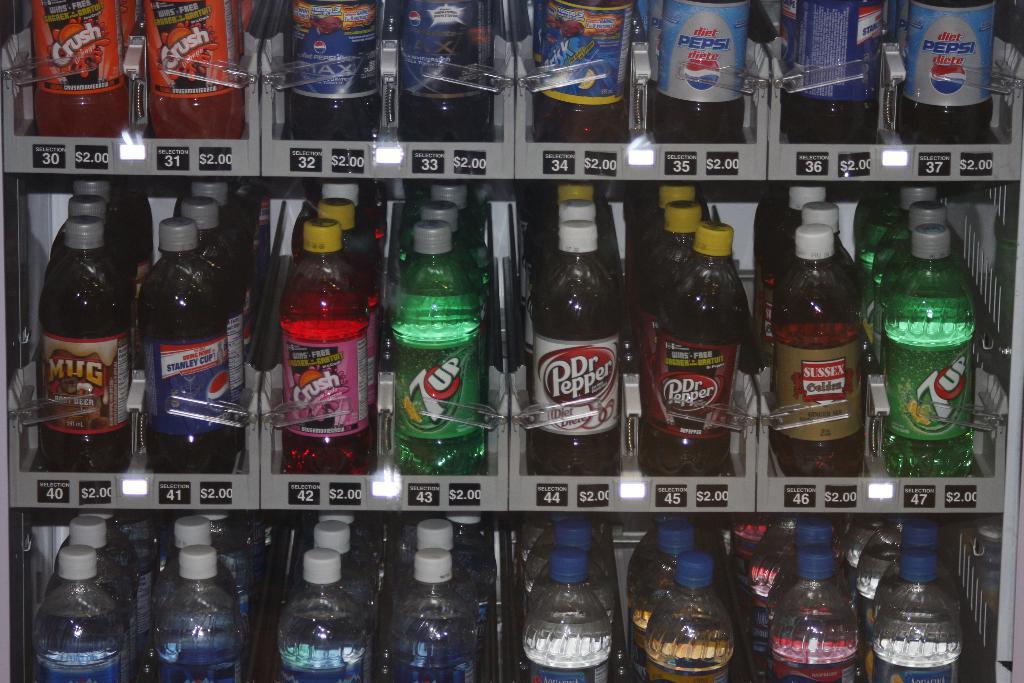What brand is in the green bottle?
Make the answer very short. 7up. 